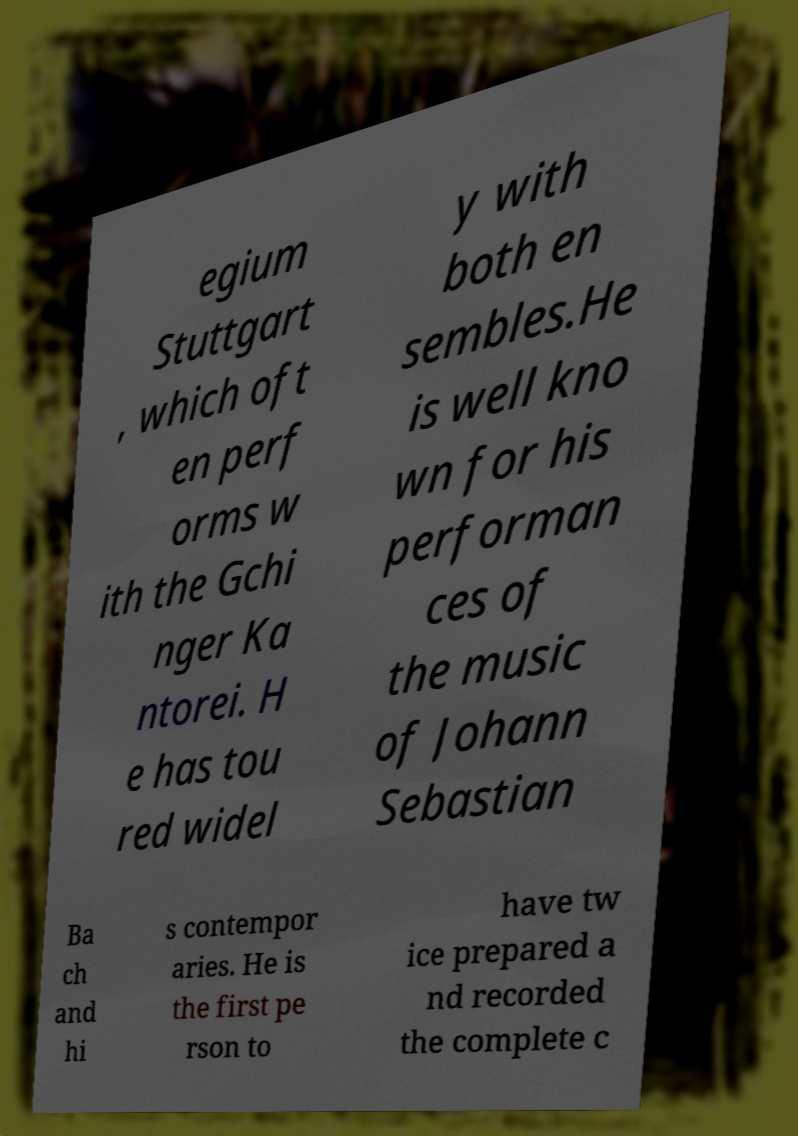There's text embedded in this image that I need extracted. Can you transcribe it verbatim? egium Stuttgart , which oft en perf orms w ith the Gchi nger Ka ntorei. H e has tou red widel y with both en sembles.He is well kno wn for his performan ces of the music of Johann Sebastian Ba ch and hi s contempor aries. He is the first pe rson to have tw ice prepared a nd recorded the complete c 